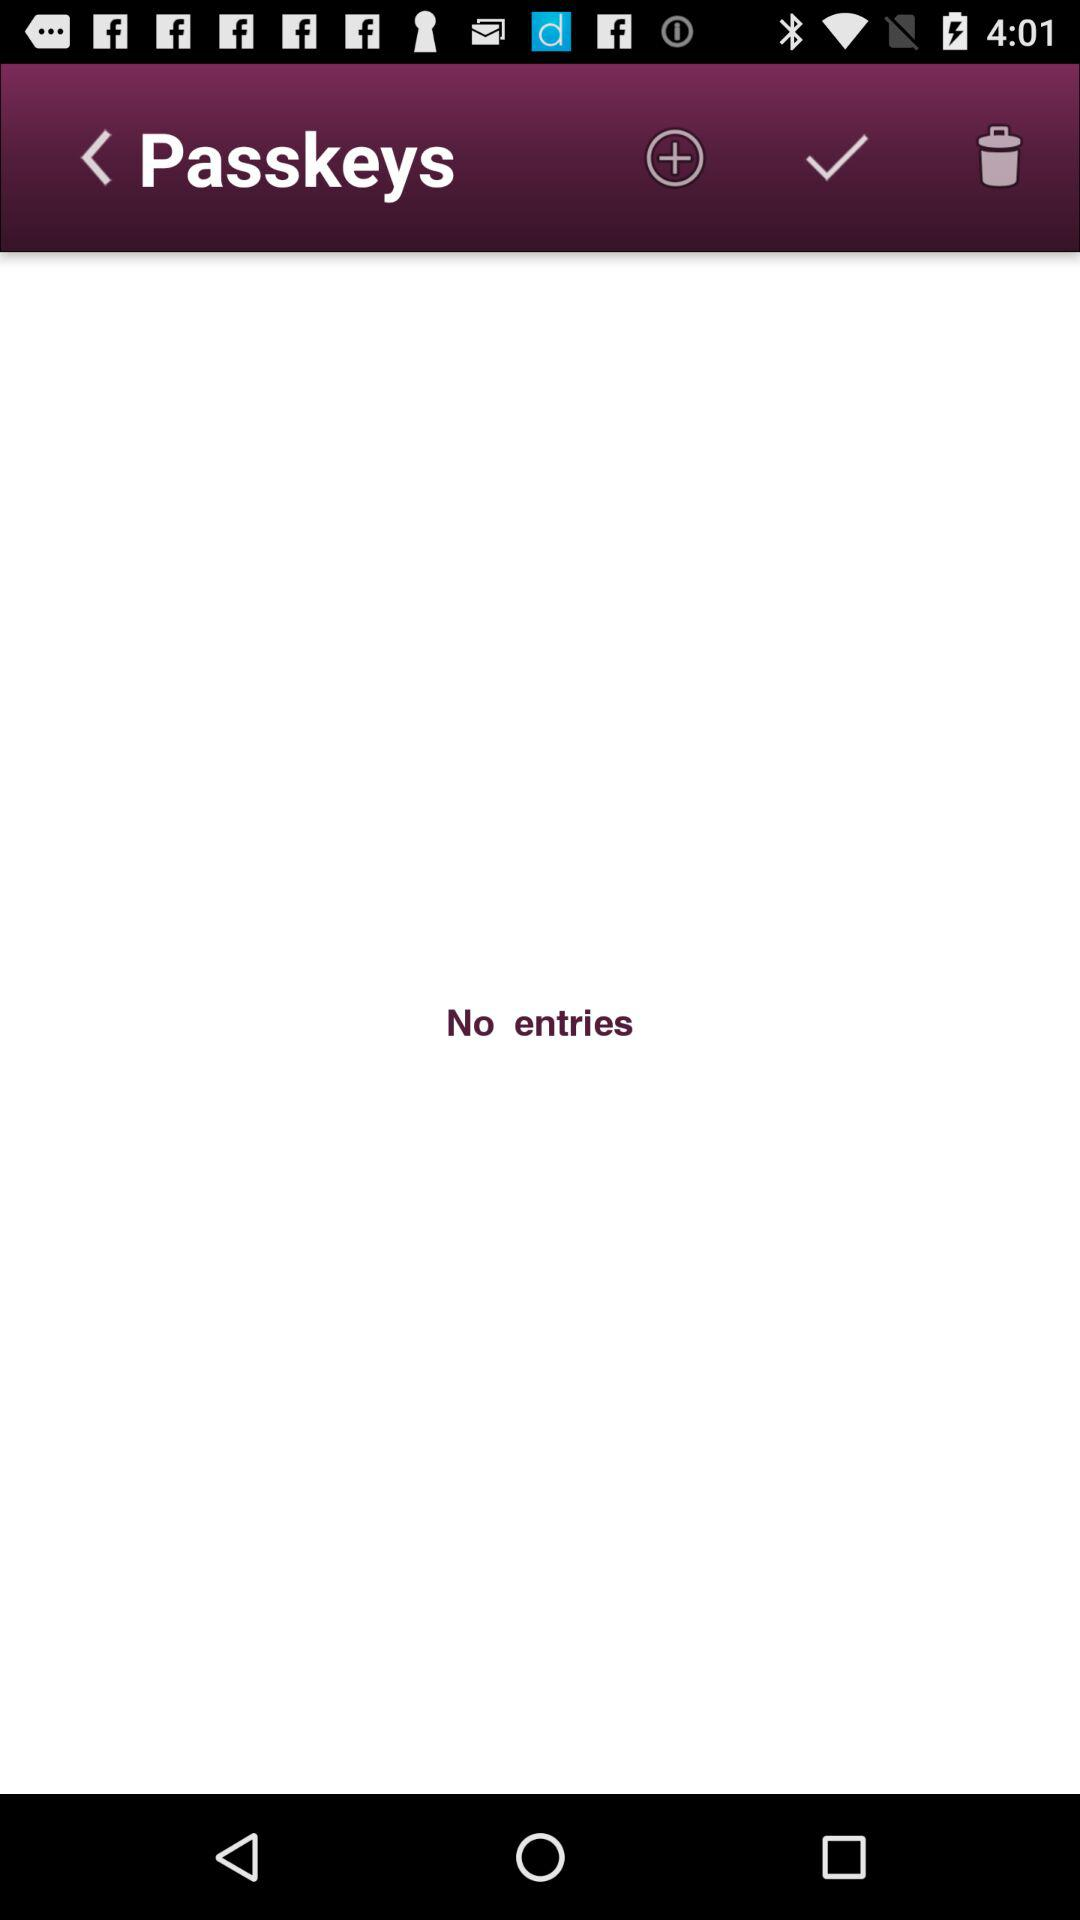Are there any entries on the screen? There are no entries. 